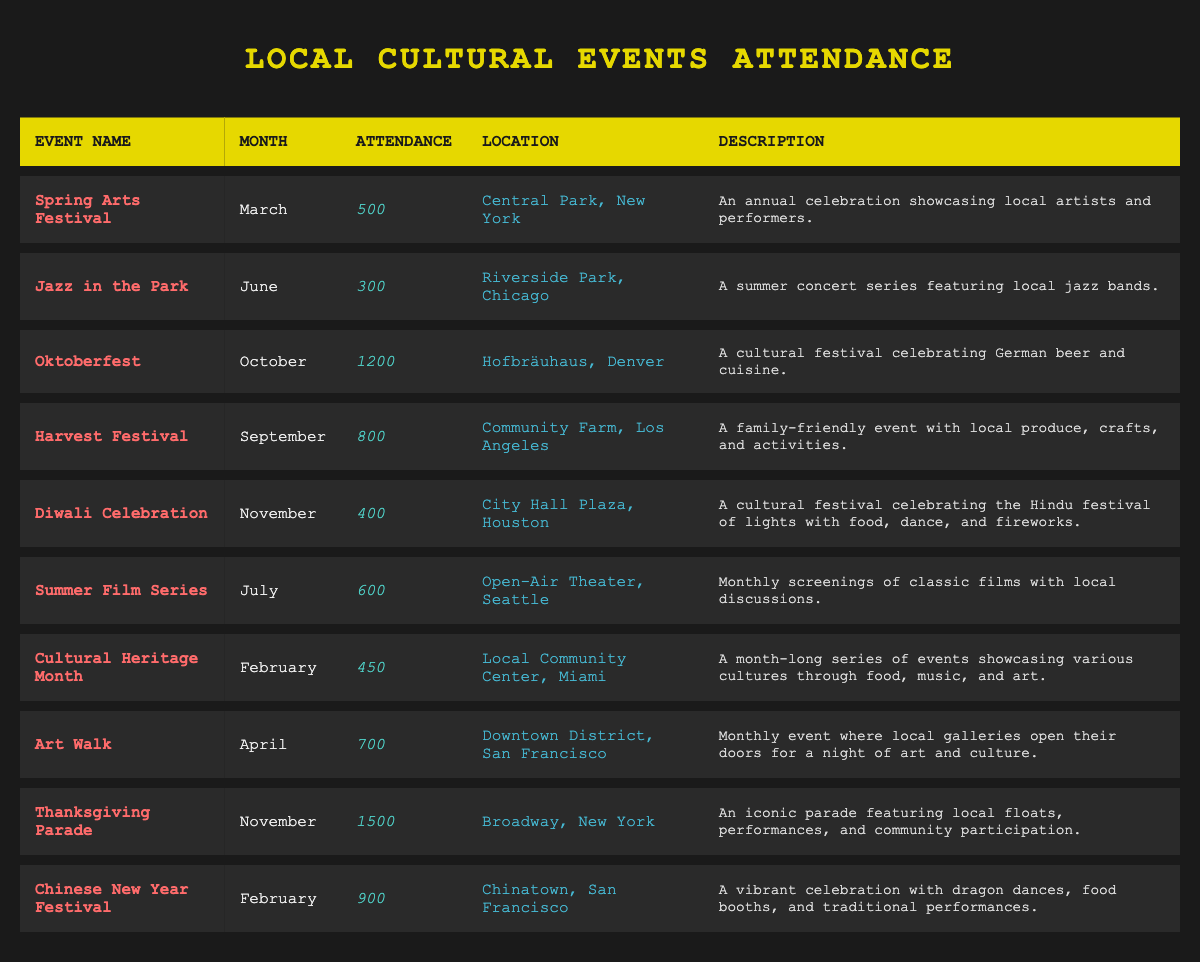What is the attendance at the Oktoberfest event? The attendance figure for the Oktoberfest event is directly listed in the table, which states 1200 for the attendance.
Answer: 1200 In which month does the Harvest Festival take place? The Harvest Festival is found in the table, and the month listed next to it is September.
Answer: September What is the total attendance for all events in November? To find the total attendance in November, I look at both events listed for that month: Diwali Celebration (400) and Thanksgiving Parade (1500). The total is calculated as 400 + 1500 = 1900.
Answer: 1900 Is the Spring Arts Festival held in March or April? The table specifies the month for the Spring Arts Festival as March, which confirms it is not held in April.
Answer: Yes Which event has the highest attendance, and what is that figure? By comparing the attendance figures for all events, the highest attendance is at the Thanksgiving Parade with 1500 attendees.
Answer: Thanksgiving Parade, 1500 What is the average attendance of events taking place in February? For February, the events listed are Cultural Heritage Month (450) and Chinese New Year Festival (900). The sum is 450 + 900 = 1350, and since there are two events, the average is 1350/2 = 675.
Answer: 675 Which event takes place in Los Angeles, and what is its attendance? Referring to the location column, the event located in Los Angeles is the Harvest Festival, and its attendance is listed as 800.
Answer: Harvest Festival, 800 Is there any event in July? The table does include one event in July, which is the Summer Film Series. Therefore, the answer is yes.
Answer: Yes What event has the same attendance as the Cultural Heritage Month? The Cultural Heritage Month has an attendance of 450, and the table shows the same attendance for the event occurring in March, which is not present. There are no other events listed with this specific figure.
Answer: No 